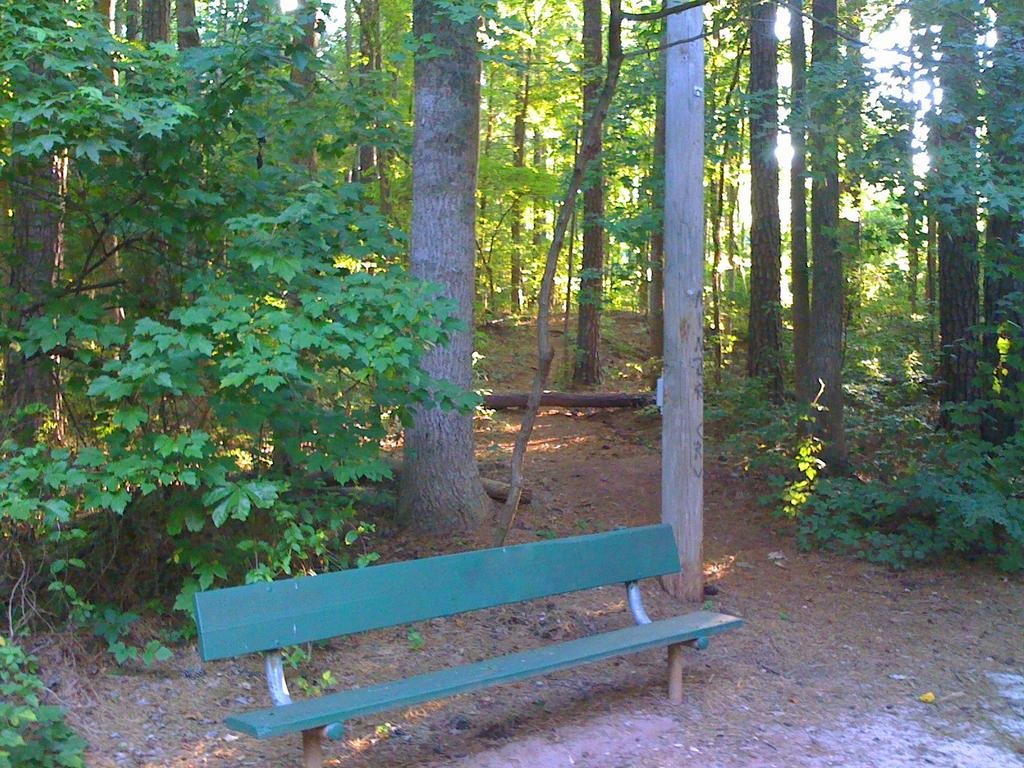What type of vegetation is present in the image? There are many trees and few plants in the image. Can you describe any man-made structures in the image? Yes, there is a bench in the image. What type of soup is being served on the bench in the image? There is no soup or any food item present in the image; it only features trees, plants, and a bench. 